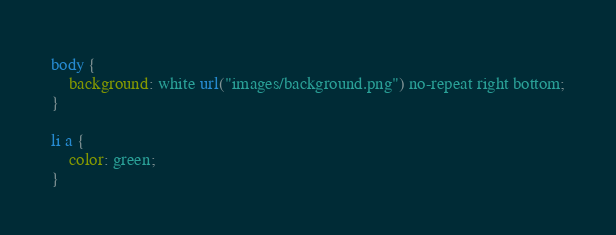<code> <loc_0><loc_0><loc_500><loc_500><_CSS_>body {
    background: white url("images/background.png") no-repeat right bottom;
}

li a {
    color: green;
}</code> 